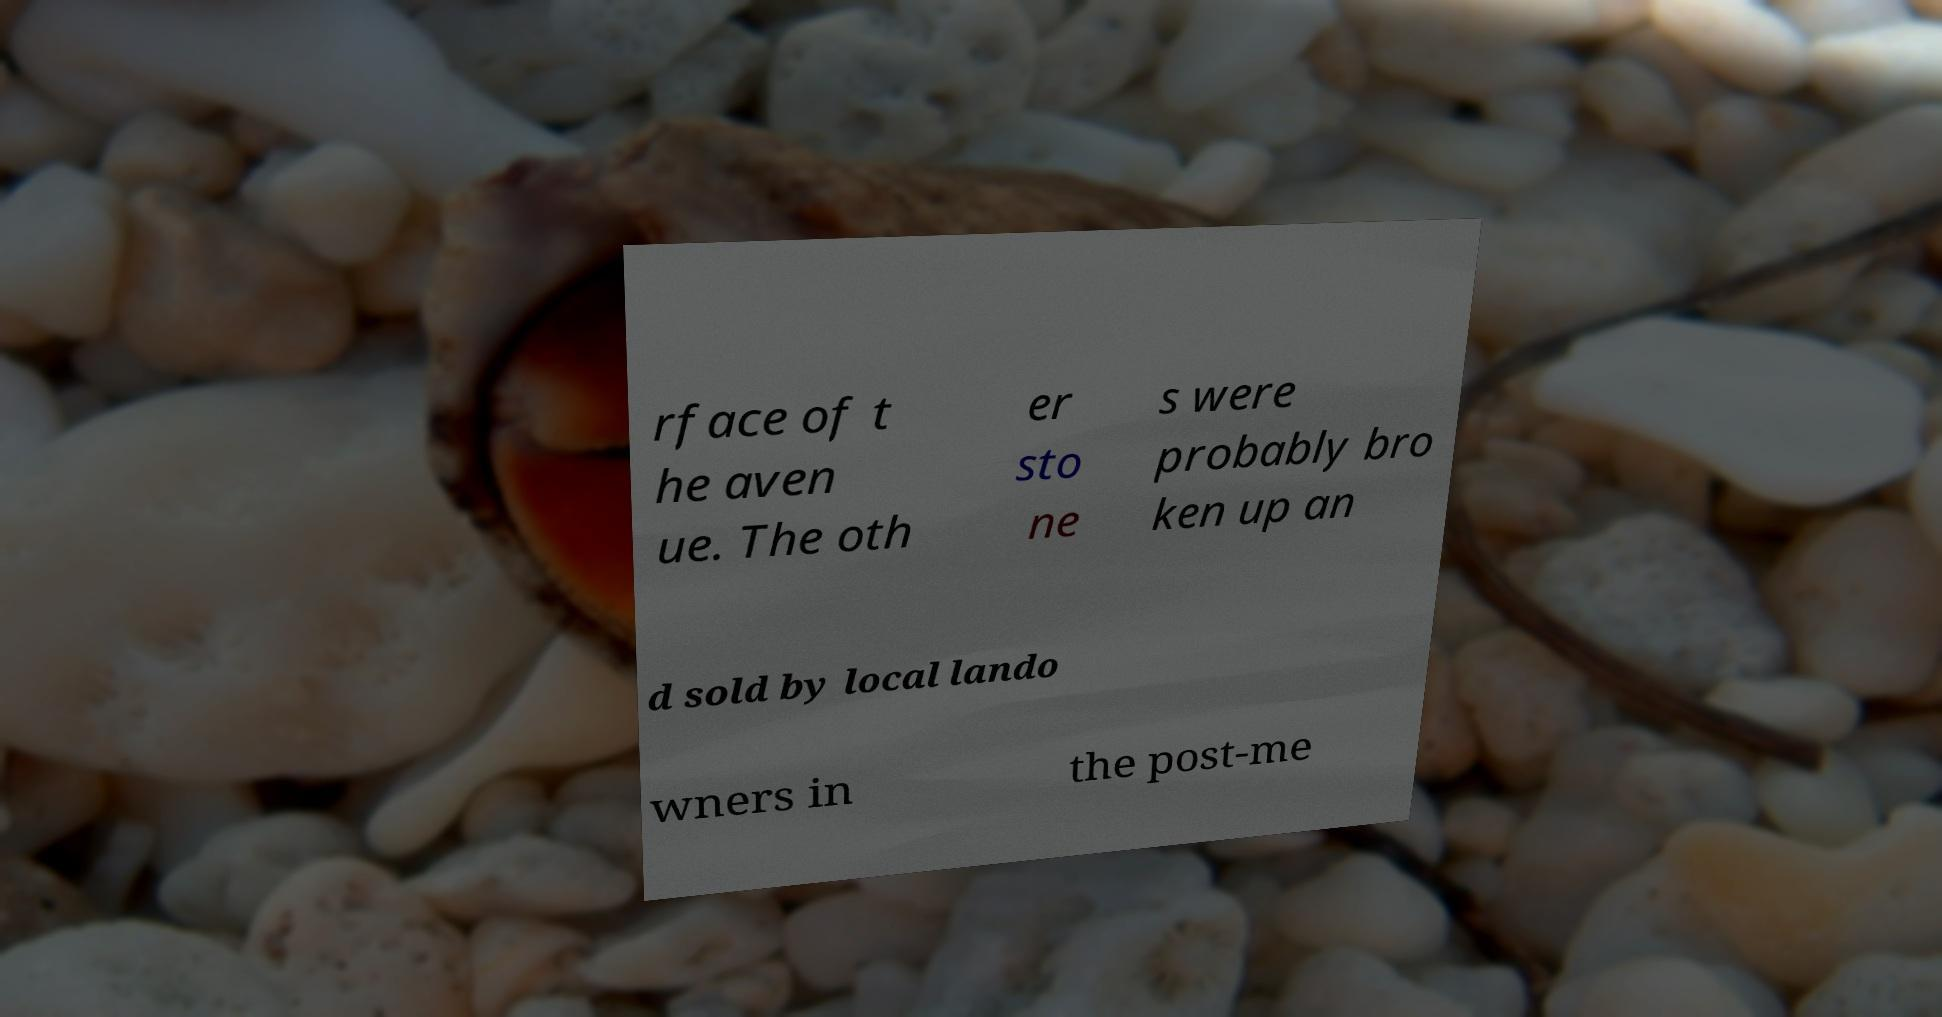For documentation purposes, I need the text within this image transcribed. Could you provide that? rface of t he aven ue. The oth er sto ne s were probably bro ken up an d sold by local lando wners in the post-me 